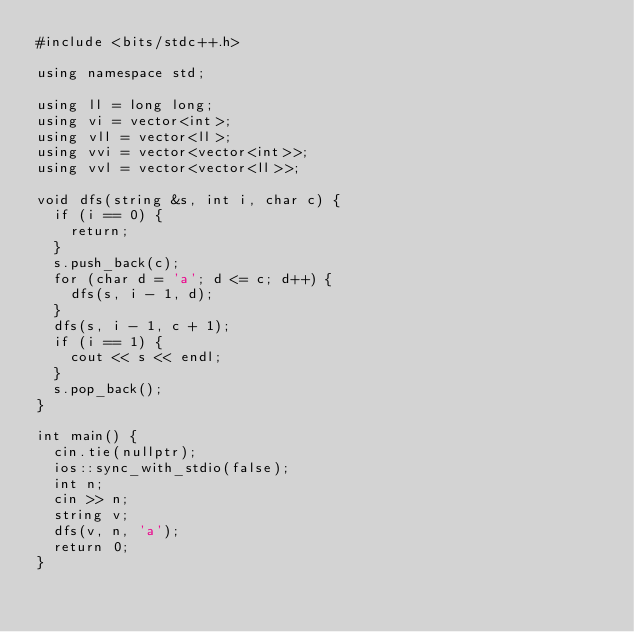Convert code to text. <code><loc_0><loc_0><loc_500><loc_500><_C++_>#include <bits/stdc++.h>

using namespace std;

using ll = long long;
using vi = vector<int>;
using vll = vector<ll>;
using vvi = vector<vector<int>>;
using vvl = vector<vector<ll>>;

void dfs(string &s, int i, char c) {
  if (i == 0) {
    return;
  }
  s.push_back(c);
  for (char d = 'a'; d <= c; d++) {
    dfs(s, i - 1, d);
  }
  dfs(s, i - 1, c + 1);
  if (i == 1) {
    cout << s << endl;
  }
  s.pop_back();
}

int main() {
  cin.tie(nullptr);
  ios::sync_with_stdio(false);
  int n;
  cin >> n;
  string v;
  dfs(v, n, 'a');
  return 0;
}
</code> 